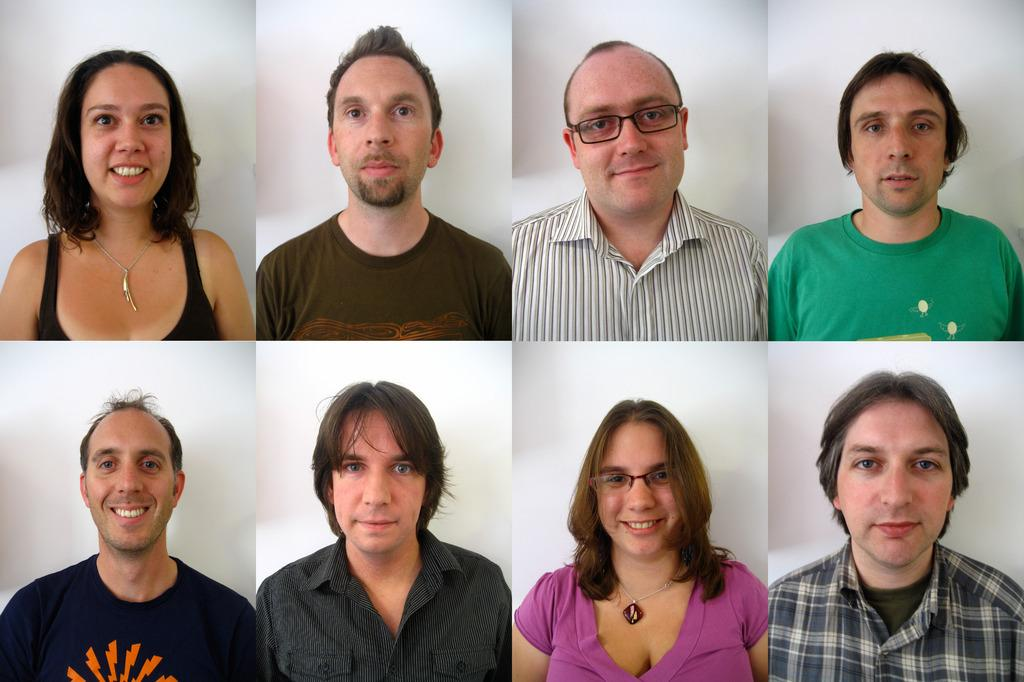How many people are in the image? There are different people in the image. What is the facial expression of the people in the image? All the people are smiling. Are any of the people wearing spectacles? Yes, two of the people are wearing spectacles. What can be seen in the background of the image? There is a white surface in the background of the image. What type of pizzas are being served to the people in the image? There is no mention of pizzas in the image; it only shows people smiling and wearing spectacles. What property is being discussed by the people in the image? There is no indication of a property-related discussion in the image. 